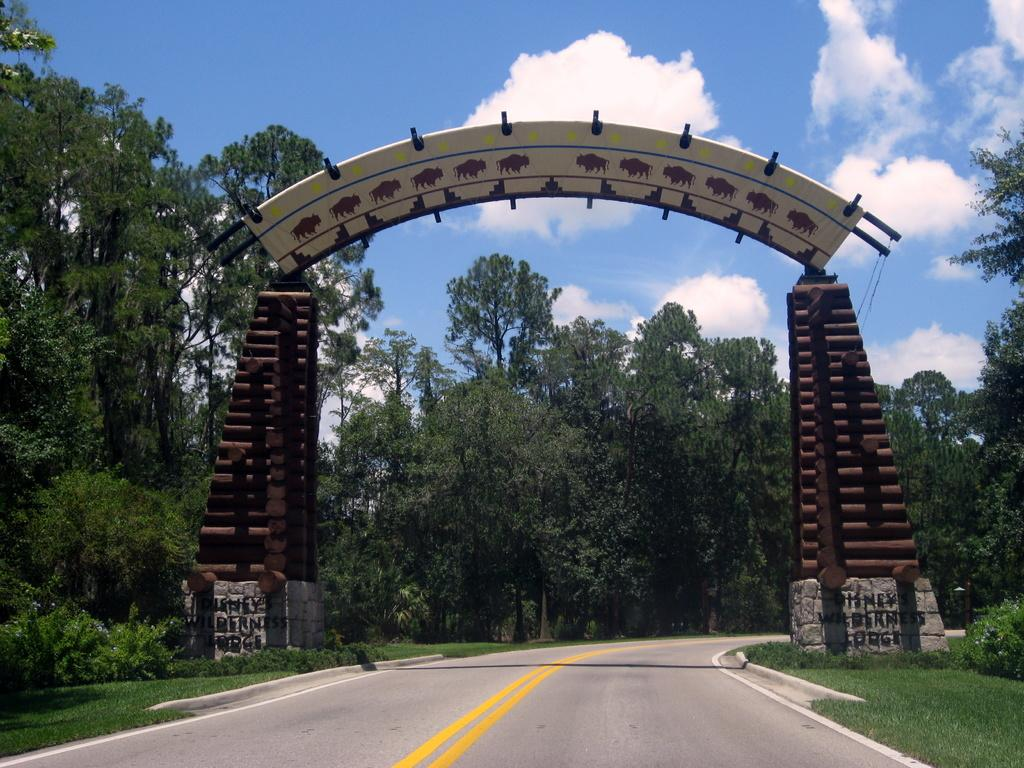What is the main feature of the image? There is a road in the image. What other structure can be seen in the image? There is an arch in the image. What type of natural elements are present in the background of the image? There are many trees and clouds visible in the background of the image. What part of the natural environment is visible in the image? The sky is visible in the background of the image. What type of meal is being prepared in the cave in the image? There is no cave or meal preparation present in the image. 